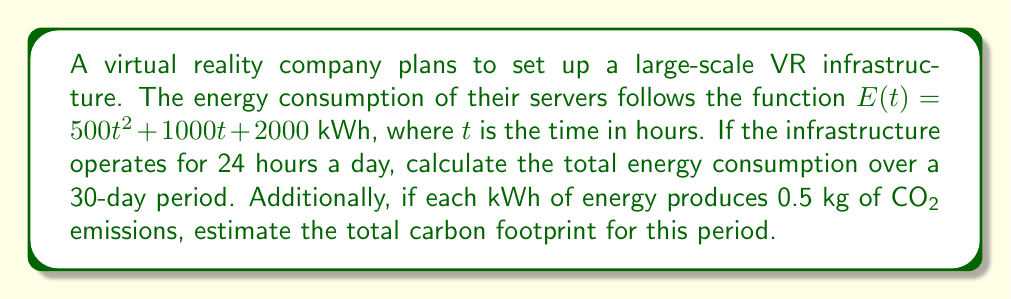What is the answer to this math problem? To solve this problem, we need to follow these steps:

1. Set up the integral to calculate total energy consumption:
   We need to integrate $E(t)$ over the period of 30 days (720 hours).
   
   $$\int_0^{720} (500t^2 + 1000t + 2000) dt$$

2. Solve the integral:
   $$\begin{aligned}
   \int_0^{720} (500t^2 + 1000t + 2000) dt &= \left[\frac{500}{3}t^3 + 500t^2 + 2000t\right]_0^{720} \\
   &= \left(\frac{500}{3}(720)^3 + 500(720)^2 + 2000(720)\right) - (0) \\
   &= \frac{500}{3}(373,248,000) + 259,200,000 + 1,440,000 \\
   &= 62,208,000 + 259,200,000 + 1,440,000 \\
   &= 322,848,000 \text{ kWh}
   \end{aligned}$$

3. Calculate the carbon footprint:
   Multiply the total energy consumption by the CO2 emission rate.
   
   $322,848,000 \text{ kWh} \times 0.5 \text{ kg/kWh} = 161,424,000 \text{ kg of CO2}$

Therefore, the total energy consumption is 322,848,000 kWh, and the carbon footprint is 161,424,000 kg of CO2 over the 30-day period.
Answer: 322,848,000 kWh; 161,424,000 kg CO2 